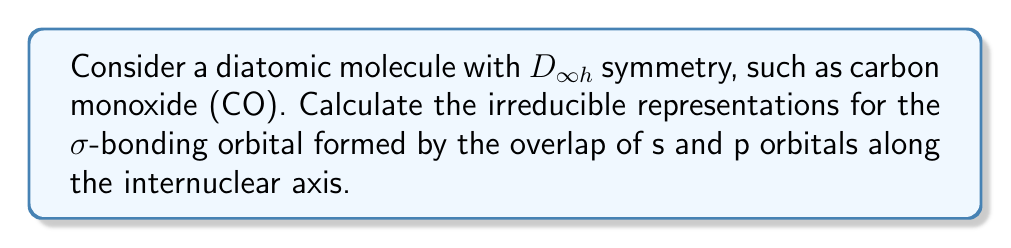Solve this math problem. As a fellow research chemist, we can approach this problem using the following steps:

1. Identify the point group: The molecule has $D_{\infty h}$ symmetry.

2. Determine the contributing atomic orbitals:
   - Carbon: 2s and 2p$_z$ orbitals
   - Oxygen: 2s and 2p$_z$ orbitals

3. Identify the symmetry species of the atomic orbitals:
   - s orbitals: $\Sigma_g^+$
   - p$_z$ orbitals: $\Sigma_u^+$

4. Combine the symmetry species:
   $$\Sigma_g^+ \otimes \Sigma_g^+ = \Sigma_g^+$$
   $$\Sigma_g^+ \otimes \Sigma_u^+ = \Sigma_u^+$$
   $$\Sigma_u^+ \otimes \Sigma_u^+ = \Sigma_g^+$$

5. The σ-bonding orbital is formed by the in-phase combination of these atomic orbitals. This results in a totally symmetric representation.

6. The totally symmetric representation in the $D_{\infty h}$ point group is $\Sigma_g^+$.

Therefore, the irreducible representation for the σ-bonding orbital in a diatomic molecule with $D_{\infty h}$ symmetry is $\Sigma_g^+$.
Answer: $\Sigma_g^+$ 